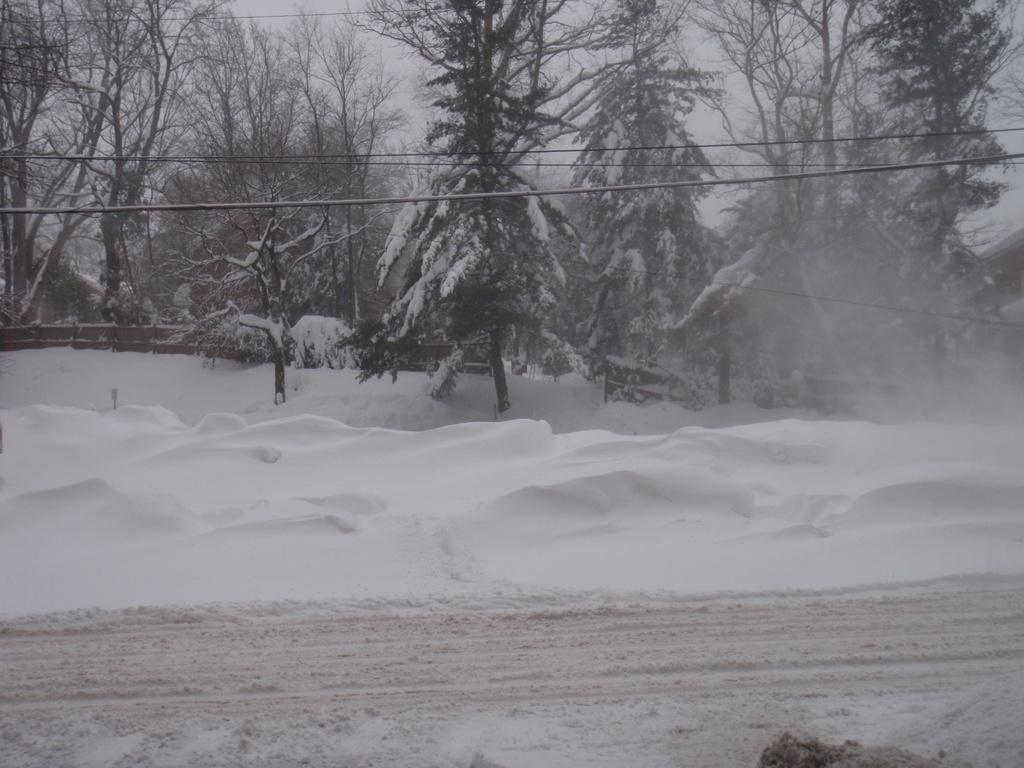What type of natural vegetation can be seen in the image? There are trees in the image. What type of infrastructure is present in the image? Cables and a fence are present in the image. What is the condition of the ground in the image? Some objects are covered by snow, and there is snow at the bottom of the image. What type of man-made path is visible in the image? There is a road in the image. What color is the silver chalk used to draw on the trees in the image? There is no silver chalk or drawing on the trees in the image; it only features trees, cables, a fence, snow, and a road. 